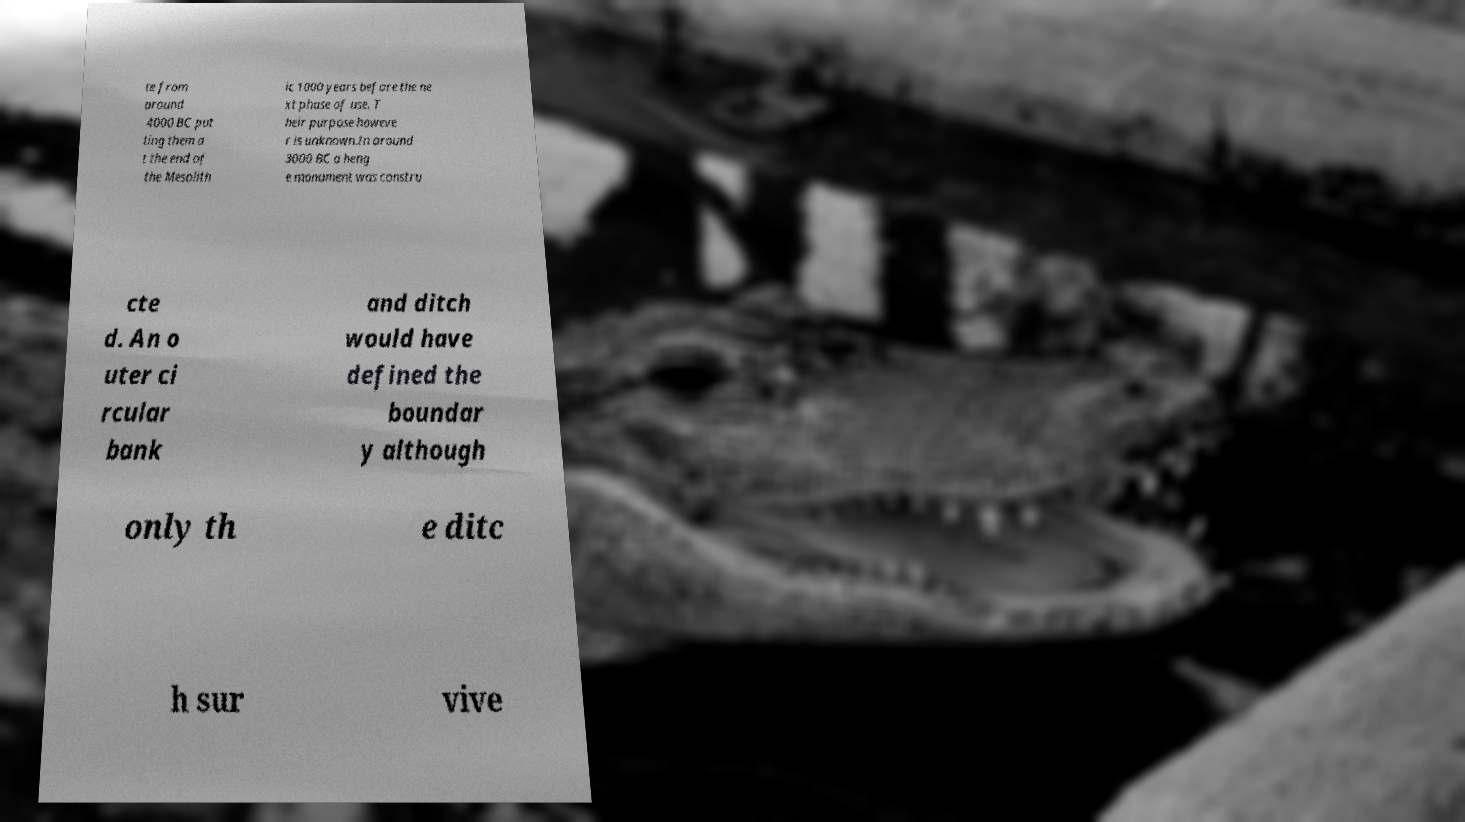Please identify and transcribe the text found in this image. te from around 4000 BC put ting them a t the end of the Mesolith ic 1000 years before the ne xt phase of use. T heir purpose howeve r is unknown.In around 3000 BC a heng e monument was constru cte d. An o uter ci rcular bank and ditch would have defined the boundar y although only th e ditc h sur vive 